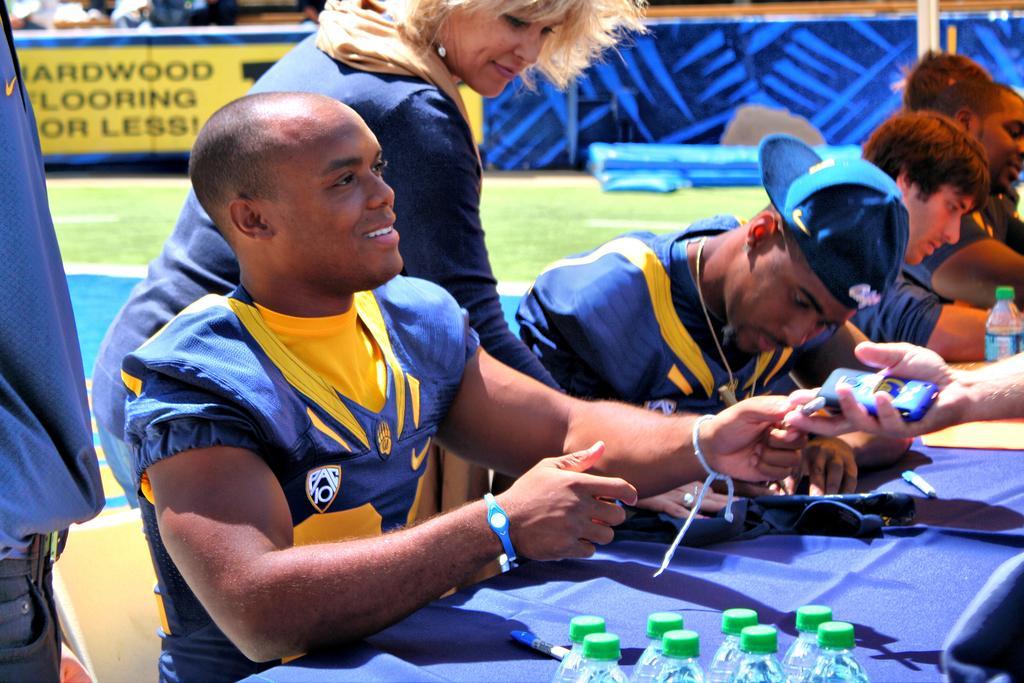How would you summarize this image in a sentence or two? In the center of the image there are people sitting on chairs. In front of them there is a table on which there is a blue color cloth and water bottles. In the background of the image there are advertisement boards. There is grass. To the left side of the image there is a person standing. In the center of the image there is a lady standing. 